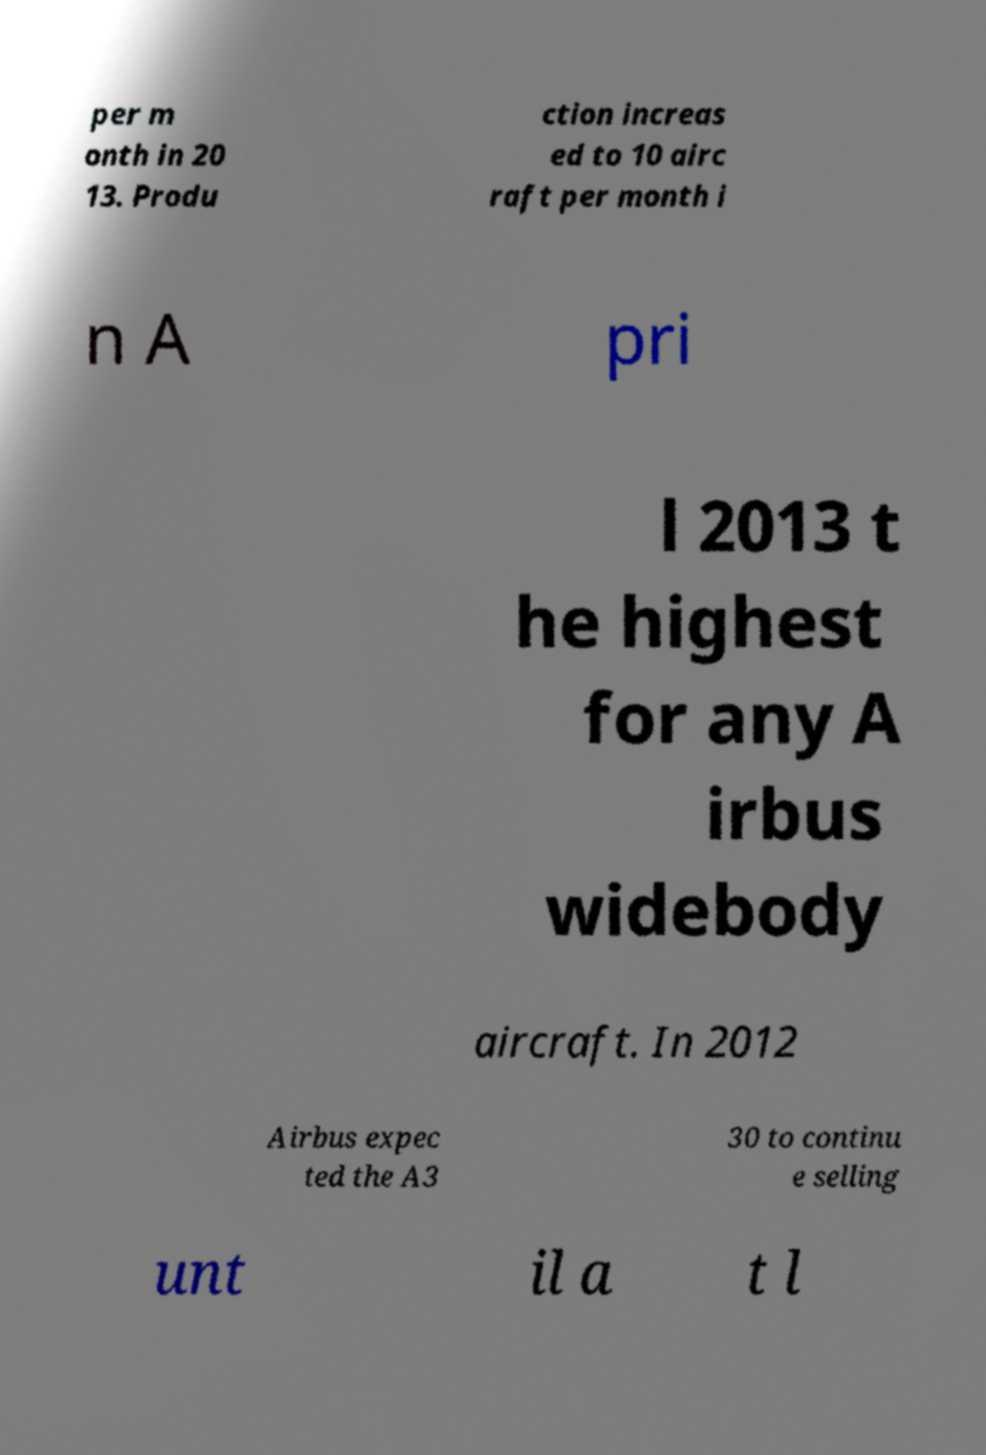Please identify and transcribe the text found in this image. per m onth in 20 13. Produ ction increas ed to 10 airc raft per month i n A pri l 2013 t he highest for any A irbus widebody aircraft. In 2012 Airbus expec ted the A3 30 to continu e selling unt il a t l 